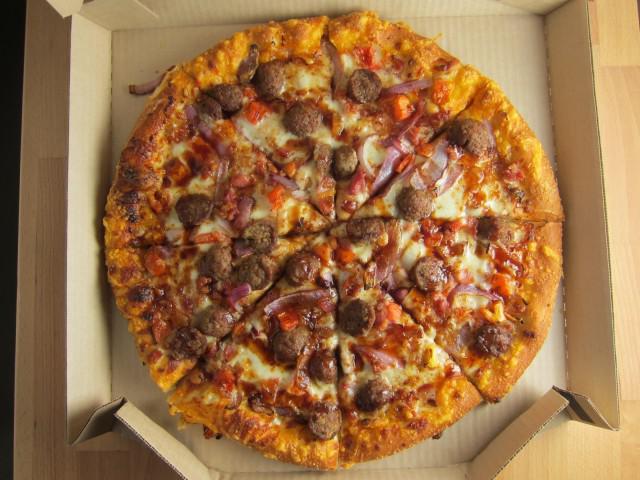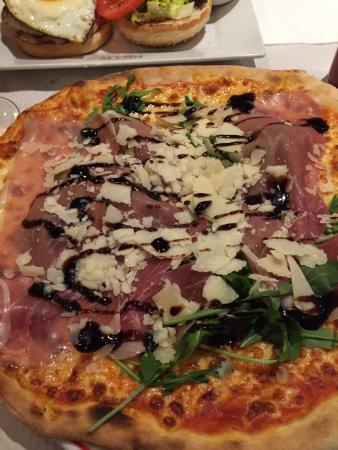The first image is the image on the left, the second image is the image on the right. For the images shown, is this caption "There is at least one rectangular shaped pizza." true? Answer yes or no. No. 